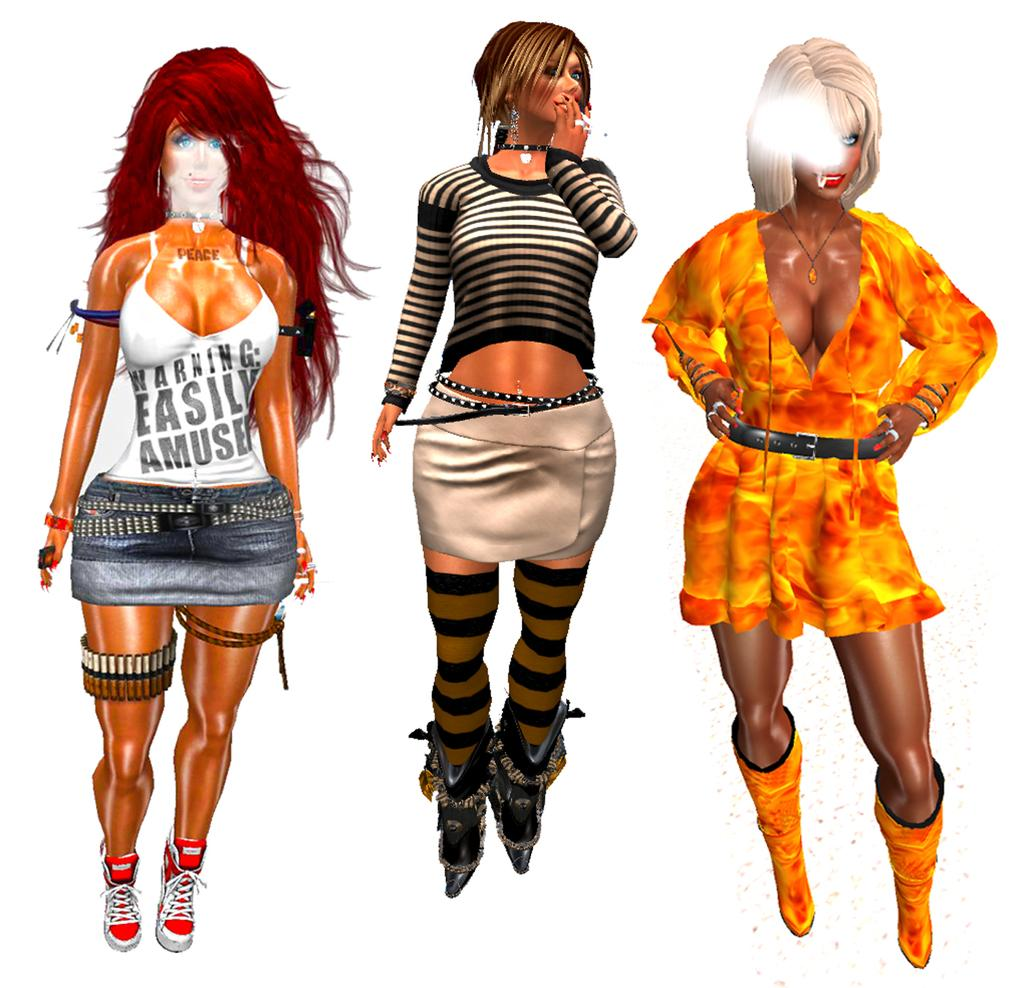What is the main subject of the image? The main subject of the image is three animated people. Can you describe the appearance of the animated people? The animated people are wearing different color dresses. What is the color of the background in the image? The background of the image is white. What type of pear can be seen in the image? There is no pear present in the image. How many vans are visible in the image? There are no vans present in the image. 